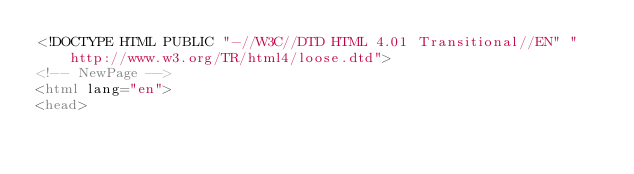<code> <loc_0><loc_0><loc_500><loc_500><_HTML_><!DOCTYPE HTML PUBLIC "-//W3C//DTD HTML 4.01 Transitional//EN" "http://www.w3.org/TR/html4/loose.dtd">
<!-- NewPage -->
<html lang="en">
<head></code> 